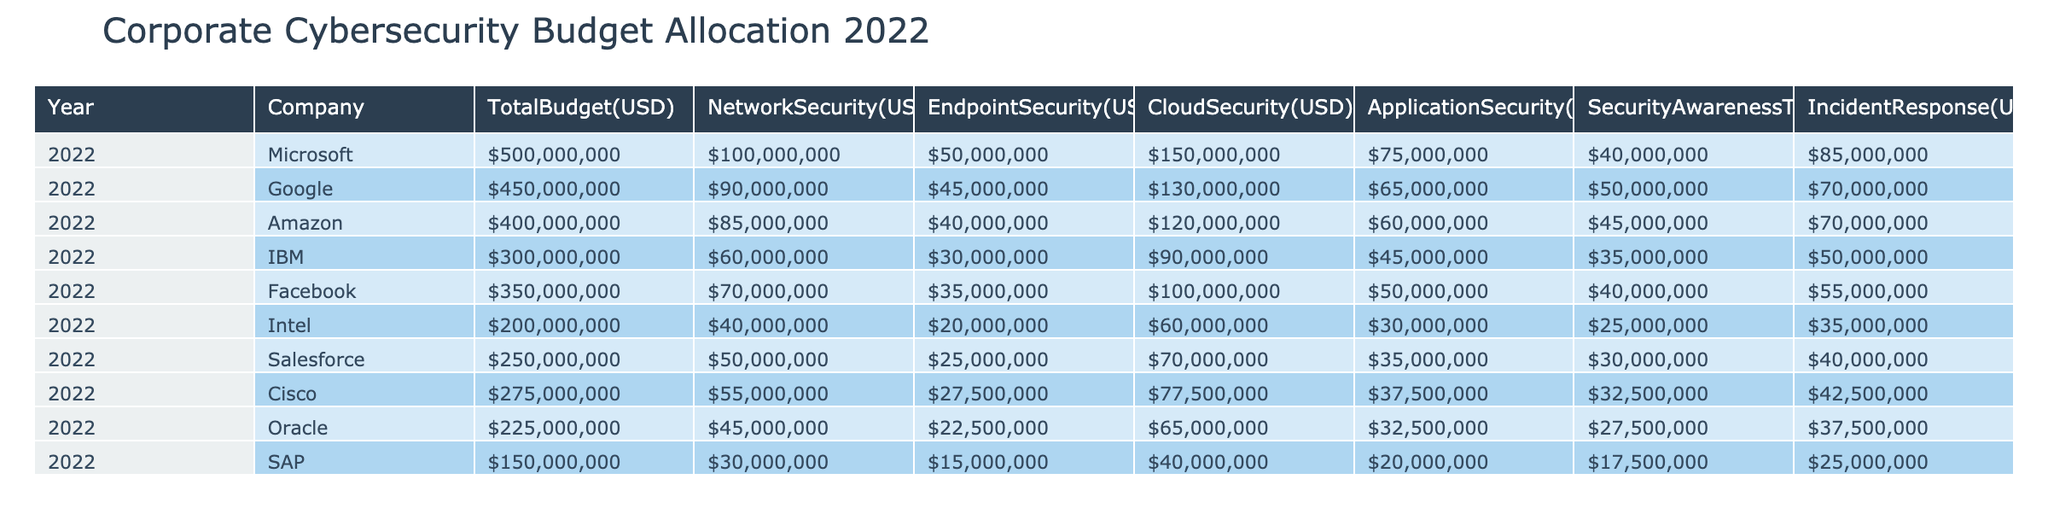What is the total cybersecurity budget allocated by Amazon in 2022? According to the table, Amazon's total cybersecurity budget for 2022 is listed under the "TotalBudget(USD)" column, which shows a value of 400000000.
Answer: 400000000 Which company allocated the highest budget for Cloud Security in 2022? In the CloudSecurity(USD) column, Microsoft has the highest budget at 150000000, while the next highest budget is Google at 130000000. Therefore, Microsoft allocated the highest budget for Cloud Security.
Answer: Microsoft What is the total allocation for Endpoint Security across all companies in 2022? To find the total allocation for Endpoint Security, we sum the values from the EndpointSecurity(USD) column: 50000000 (Microsoft) + 45000000 (Google) + 40000000 (Amazon) + 30000000 (IBM) + 35000000 (Facebook) + 20000000 (Intel) + 25000000 (Salesforce) + 27500000 (Cisco) + 22500000 (Oracle) + 15000000 (SAP) = 290000000.
Answer: 290000000 Is it true that Facebook spent more on Incident Response than Intel in 2022? Looking at the values in the IncidentResponse(USD) column, Facebook has an allocation of 55000000, while Intel's is 35000000. Since 55000000 is greater than 35000000, the statement is true.
Answer: Yes What is the average budget for Security Awareness Training across all listed companies in 2022? To calculate the average, we first sum the values from the SecurityAwarenessTraining(USD) column: 40000000 (Microsoft) + 50000000 (Google) + 45000000 (Amazon) + 35000000 (IBM) + 40000000 (Facebook) + 25000000 (Intel) + 30000000 (Salesforce) + 32500000 (Cisco) + 27500000 (Oracle) + 17500000 (SAP) = 320000000. There are 10 companies, so the average is 320000000 / 10 = 32000000.
Answer: 32000000 Which company had the lowest total budget allocation in 2022? The total budgets are listed in the TotalBudget(USD) column, and the lowest amount is 150000000 for SAP.
Answer: SAP 